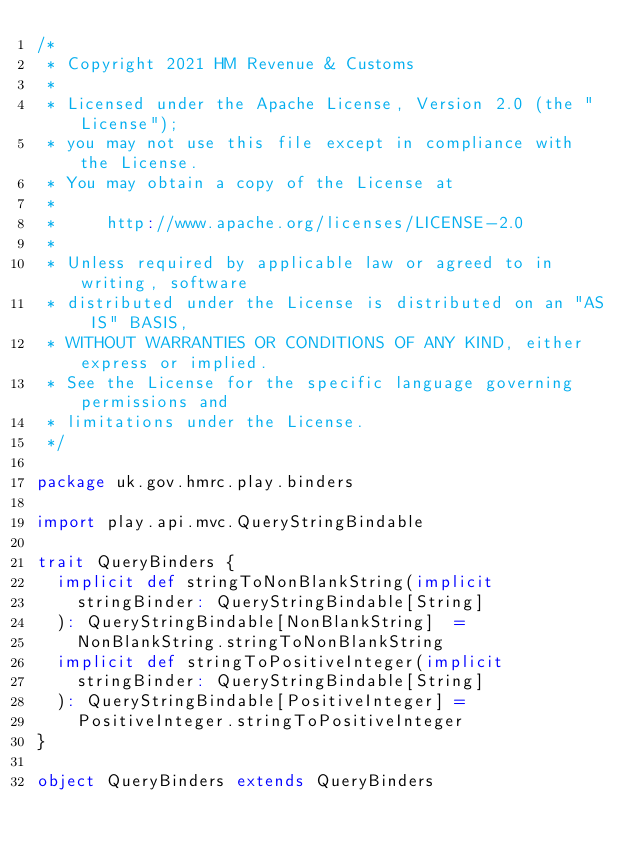Convert code to text. <code><loc_0><loc_0><loc_500><loc_500><_Scala_>/*
 * Copyright 2021 HM Revenue & Customs
 *
 * Licensed under the Apache License, Version 2.0 (the "License");
 * you may not use this file except in compliance with the License.
 * You may obtain a copy of the License at
 *
 *     http://www.apache.org/licenses/LICENSE-2.0
 *
 * Unless required by applicable law or agreed to in writing, software
 * distributed under the License is distributed on an "AS IS" BASIS,
 * WITHOUT WARRANTIES OR CONDITIONS OF ANY KIND, either express or implied.
 * See the License for the specific language governing permissions and
 * limitations under the License.
 */

package uk.gov.hmrc.play.binders

import play.api.mvc.QueryStringBindable

trait QueryBinders {
  implicit def stringToNonBlankString(implicit
    stringBinder: QueryStringBindable[String]
  ): QueryStringBindable[NonBlankString]  =
    NonBlankString.stringToNonBlankString
  implicit def stringToPositiveInteger(implicit
    stringBinder: QueryStringBindable[String]
  ): QueryStringBindable[PositiveInteger] =
    PositiveInteger.stringToPositiveInteger
}

object QueryBinders extends QueryBinders
</code> 